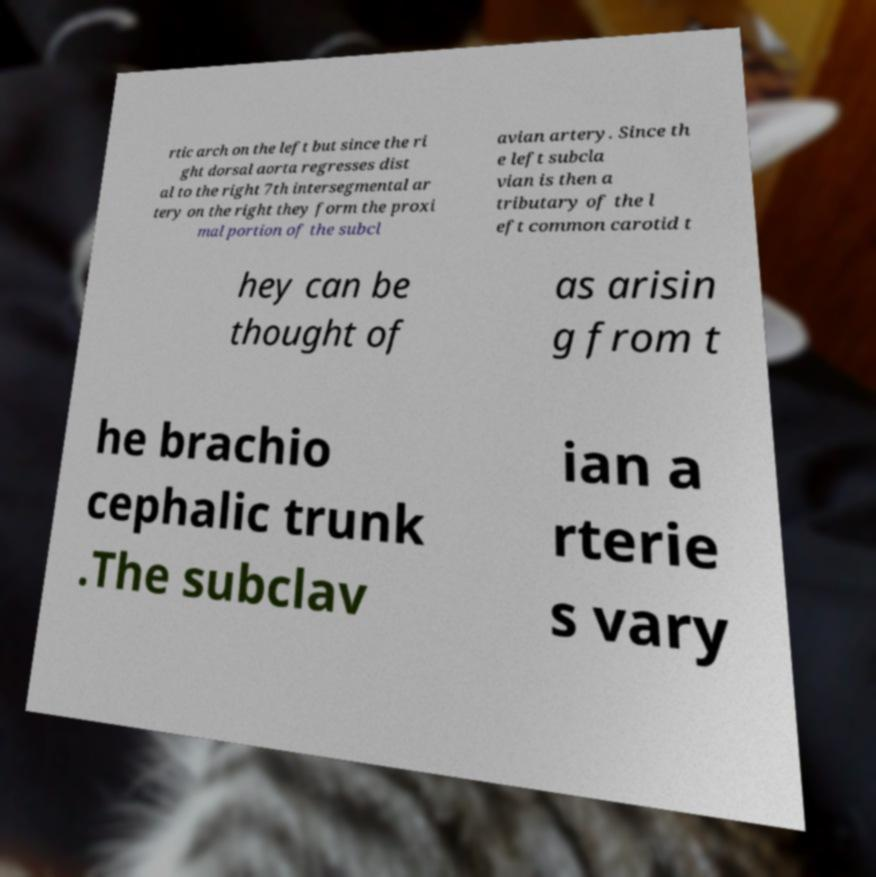Could you extract and type out the text from this image? rtic arch on the left but since the ri ght dorsal aorta regresses dist al to the right 7th intersegmental ar tery on the right they form the proxi mal portion of the subcl avian artery. Since th e left subcla vian is then a tributary of the l eft common carotid t hey can be thought of as arisin g from t he brachio cephalic trunk .The subclav ian a rterie s vary 